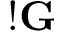Convert formula to latex. <formula><loc_0><loc_0><loc_500><loc_500>! \mathbf G</formula> 